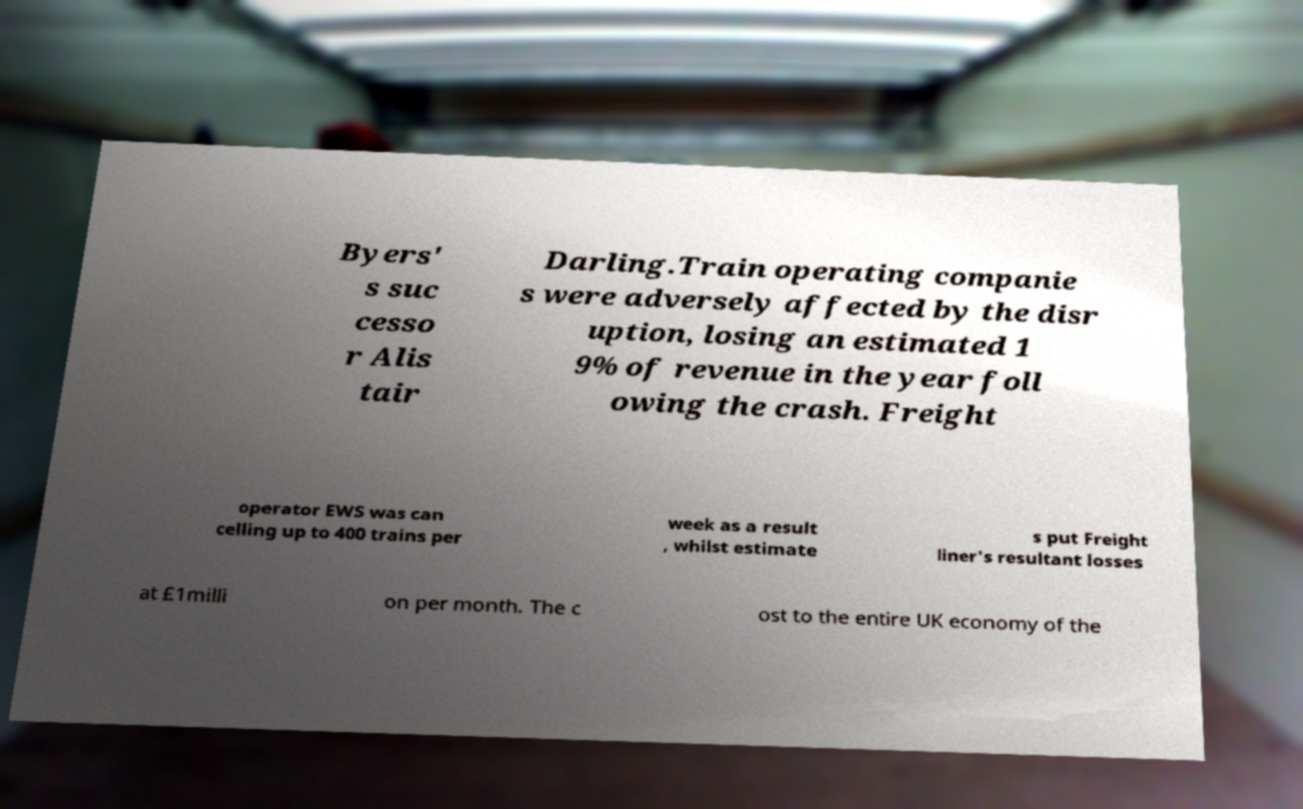Could you extract and type out the text from this image? Byers' s suc cesso r Alis tair Darling.Train operating companie s were adversely affected by the disr uption, losing an estimated 1 9% of revenue in the year foll owing the crash. Freight operator EWS was can celling up to 400 trains per week as a result , whilst estimate s put Freight liner's resultant losses at £1milli on per month. The c ost to the entire UK economy of the 